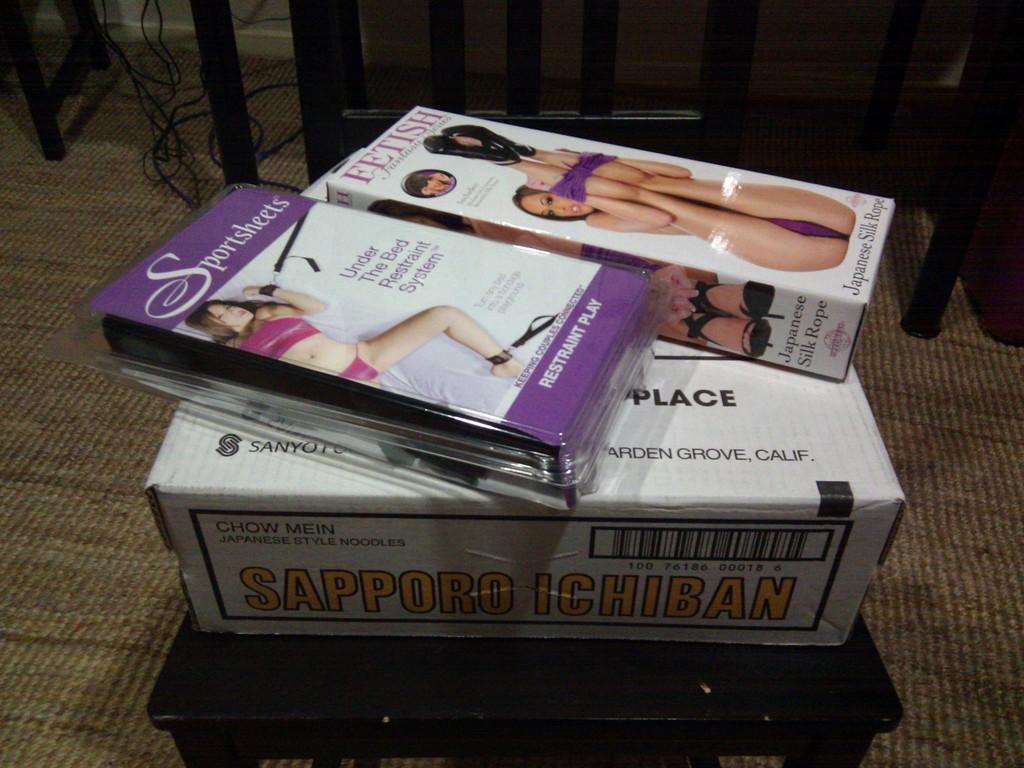What is the product in the clear plastic container?
Your answer should be compact. Sportsheets. What is in the box?
Make the answer very short. Sapporo ichiban. 